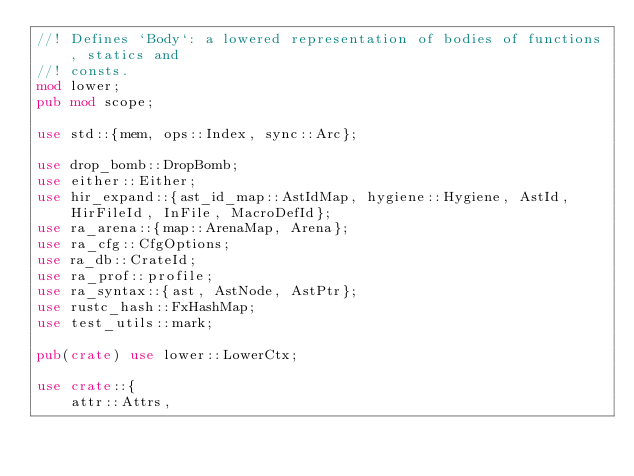Convert code to text. <code><loc_0><loc_0><loc_500><loc_500><_Rust_>//! Defines `Body`: a lowered representation of bodies of functions, statics and
//! consts.
mod lower;
pub mod scope;

use std::{mem, ops::Index, sync::Arc};

use drop_bomb::DropBomb;
use either::Either;
use hir_expand::{ast_id_map::AstIdMap, hygiene::Hygiene, AstId, HirFileId, InFile, MacroDefId};
use ra_arena::{map::ArenaMap, Arena};
use ra_cfg::CfgOptions;
use ra_db::CrateId;
use ra_prof::profile;
use ra_syntax::{ast, AstNode, AstPtr};
use rustc_hash::FxHashMap;
use test_utils::mark;

pub(crate) use lower::LowerCtx;

use crate::{
    attr::Attrs,</code> 